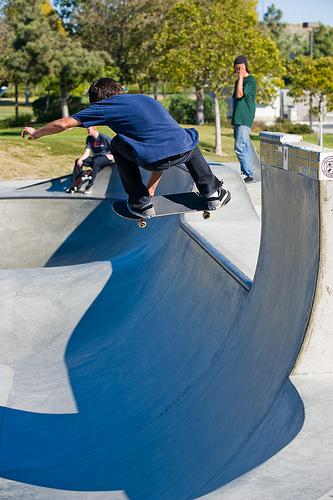Question: what are they doing?
Choices:
A. Skating.
B. Dancing.
C. Running.
D. Fighting.
Answer with the letter. Answer: A Question: what is the color of the leaves?
Choices:
A. Orange.
B. Green.
C. Red.
D. Brown.
Answer with the letter. Answer: B Question: where is the shadow?
Choices:
A. On the car.
B. On the house.
C. On the building.
D. In the ground.
Answer with the letter. Answer: D 